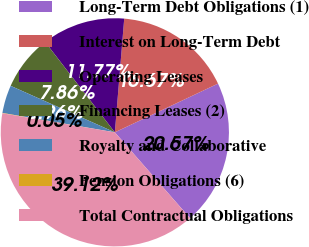Convert chart to OTSL. <chart><loc_0><loc_0><loc_500><loc_500><pie_chart><fcel>Long-Term Debt Obligations (1)<fcel>Interest on Long-Term Debt<fcel>Operating Leases<fcel>Financing Leases (2)<fcel>Royalty and Collaborative<fcel>Pension Obligations (6)<fcel>Total Contractual Obligations<nl><fcel>20.57%<fcel>16.67%<fcel>11.77%<fcel>7.86%<fcel>3.96%<fcel>0.05%<fcel>39.12%<nl></chart> 